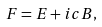Convert formula to latex. <formula><loc_0><loc_0><loc_500><loc_500>F = E + i c B ,</formula> 